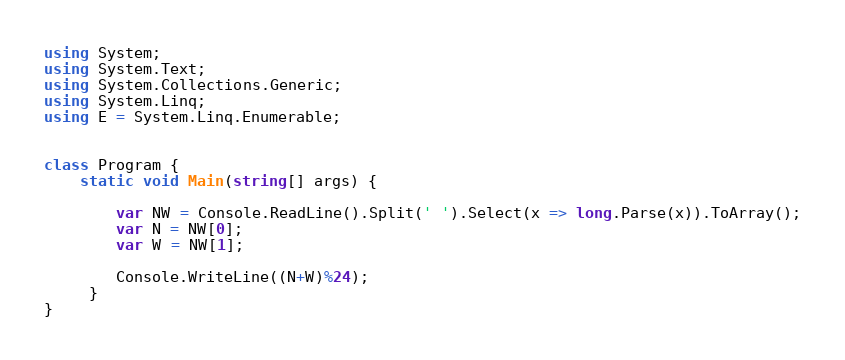<code> <loc_0><loc_0><loc_500><loc_500><_C#_>using System; 
using System.Text;
using System.Collections.Generic; 
using System.Linq; 
using E = System.Linq.Enumerable; 


class Program {
    static void Main(string[] args) {
        
        var NW = Console.ReadLine().Split(' ').Select(x => long.Parse(x)).ToArray();
        var N = NW[0];
        var W = NW[1];
        
        Console.WriteLine((N+W)%24);
     }
}
</code> 